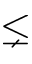Convert formula to latex. <formula><loc_0><loc_0><loc_500><loc_500>\lneq</formula> 